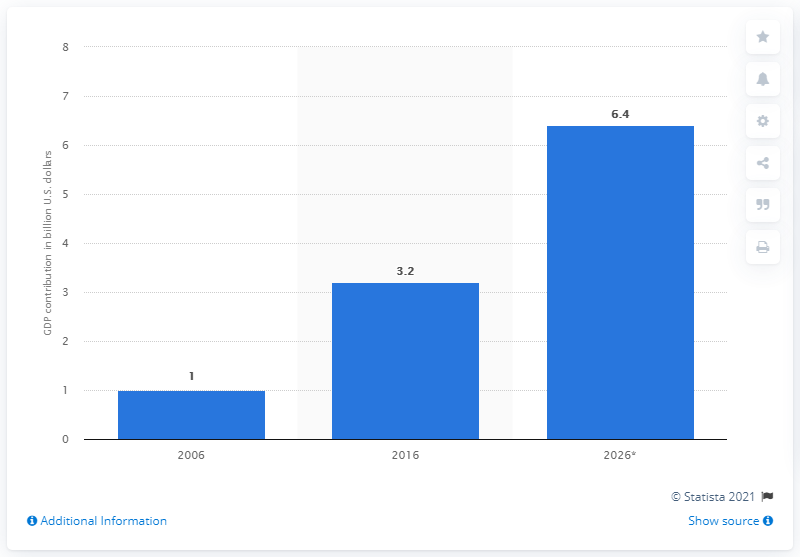Draw attention to some important aspects in this diagram. The direct tourism contribution of Abu Dhabi to the GDP of the United Arab Emirates in 2026 was estimated to be 6.4%. 